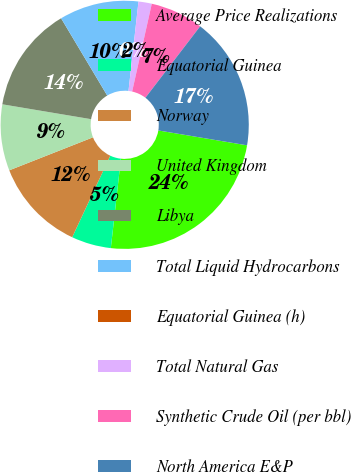<chart> <loc_0><loc_0><loc_500><loc_500><pie_chart><fcel>Average Price Realizations<fcel>Equatorial Guinea<fcel>Norway<fcel>United Kingdom<fcel>Libya<fcel>Total Liquid Hydrocarbons<fcel>Equatorial Guinea (h)<fcel>Total Natural Gas<fcel>Synthetic Crude Oil (per bbl)<fcel>North America E&P<nl><fcel>24.14%<fcel>5.17%<fcel>12.07%<fcel>8.62%<fcel>13.79%<fcel>10.34%<fcel>0.0%<fcel>1.73%<fcel>6.9%<fcel>17.24%<nl></chart> 